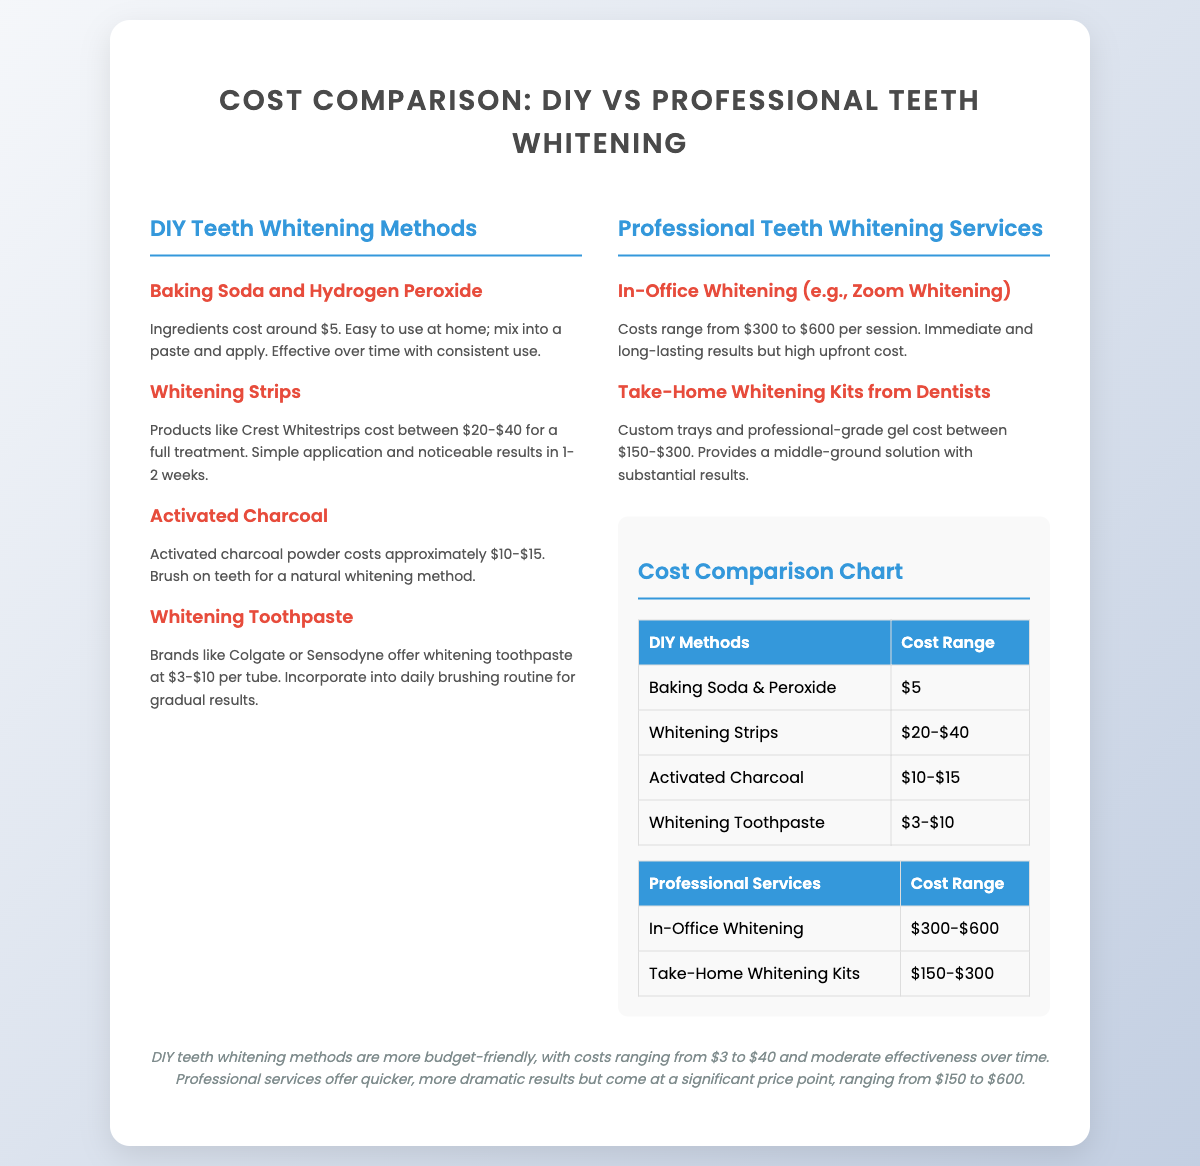What is the cost of baking soda and hydrogen peroxide? The cost of baking soda and hydrogen peroxide is approximately $5.
Answer: $5 What is the maximum price for in-office whitening? In-office whitening costs range up to $600 per session.
Answer: $600 What is the cost range for whitening strips? Whitening strips range from $20 to $40 for a full treatment.
Answer: $20-$40 Which DIY method has the lowest cost? Whitening toothpaste prices start from $3, making it the lowest cost method.
Answer: $3 How much do take-home whitening kits cost? Take-home whitening kits from dentists cost between $150 and $300.
Answer: $150-$300 Which whitening method provides immediate results? In-office whitening provides immediate results.
Answer: In-office whitening Compare the cost of DIY methods with professional methods. DIY methods cost ranges from $3 to $40, while professional services range from $150 to $600.
Answer: $3-$40 vs. $150-$600 What color is used for the headings in the DIY methods section? The headings in the DIY methods section are colored blue.
Answer: Blue How many DIY methods are listed on the slide? There are four DIY methods listed on the slide.
Answer: Four 